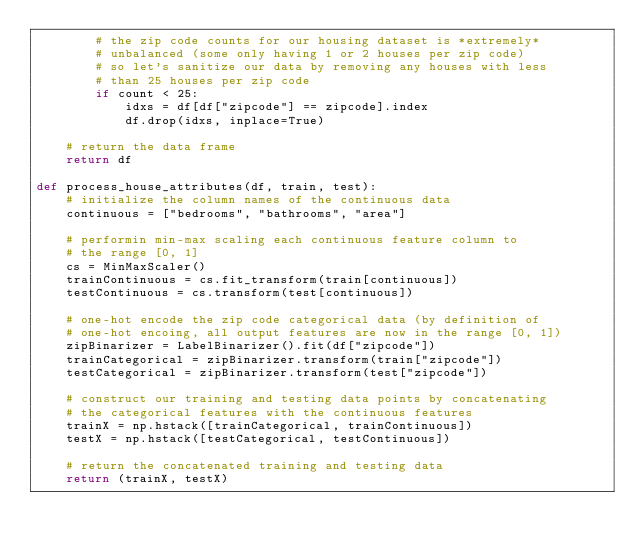<code> <loc_0><loc_0><loc_500><loc_500><_Python_>		# the zip code counts for our housing dataset is *extremely*
		# unbalanced (some only having 1 or 2 houses per zip code)
		# so let's sanitize our data by removing any houses with less
		# than 25 houses per zip code
		if count < 25:
			idxs = df[df["zipcode"] == zipcode].index
			df.drop(idxs, inplace=True)
	
	# return the data frame
	return df

def process_house_attributes(df, train, test):
	# initialize the column names of the continuous data
	continuous = ["bedrooms", "bathrooms", "area"]
	
	# performin min-max scaling each continuous feature column to
	# the range [0, 1]
	cs = MinMaxScaler()
	trainContinuous = cs.fit_transform(train[continuous])
	testContinuous = cs.transform(test[continuous])
	
	# one-hot encode the zip code categorical data (by definition of
	# one-hot encoing, all output features are now in the range [0, 1])
	zipBinarizer = LabelBinarizer().fit(df["zipcode"])
	trainCategorical = zipBinarizer.transform(train["zipcode"])
	testCategorical = zipBinarizer.transform(test["zipcode"])
	
	# construct our training and testing data points by concatenating
	# the categorical features with the continuous features
	trainX = np.hstack([trainCategorical, trainContinuous])
	testX = np.hstack([testCategorical, testContinuous])
	
	# return the concatenated training and testing data
	return (trainX, testX)
</code> 